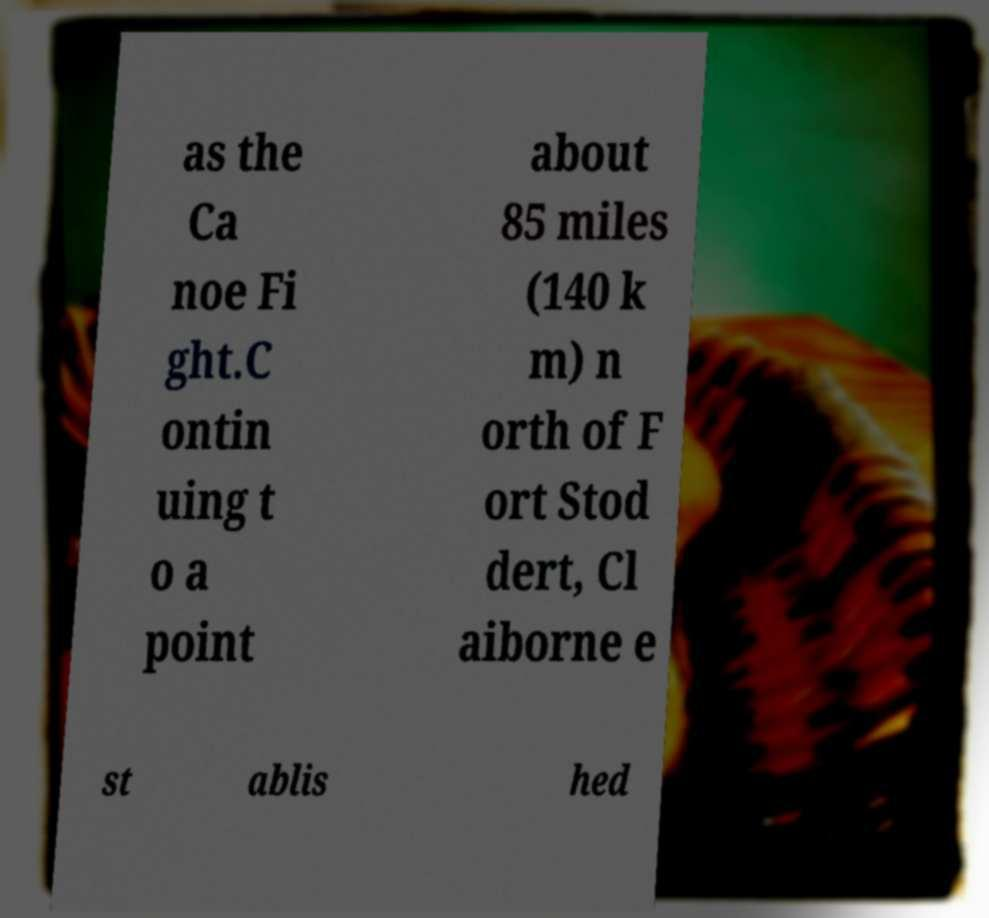There's text embedded in this image that I need extracted. Can you transcribe it verbatim? as the Ca noe Fi ght.C ontin uing t o a point about 85 miles (140 k m) n orth of F ort Stod dert, Cl aiborne e st ablis hed 